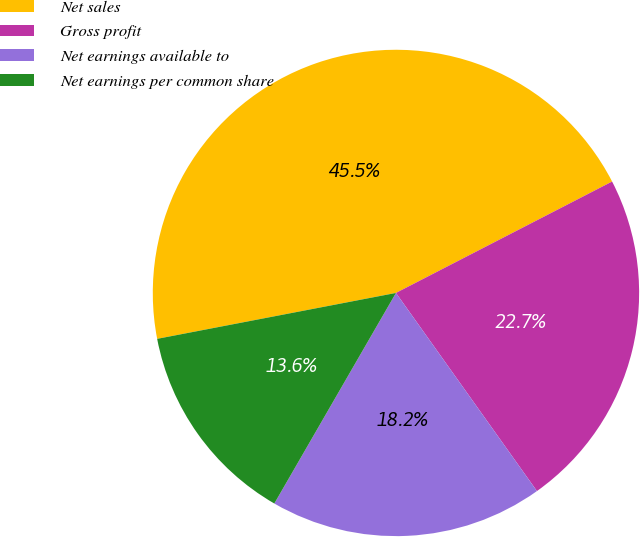<chart> <loc_0><loc_0><loc_500><loc_500><pie_chart><fcel>Net sales<fcel>Gross profit<fcel>Net earnings available to<fcel>Net earnings per common share<nl><fcel>45.45%<fcel>22.73%<fcel>18.18%<fcel>13.64%<nl></chart> 